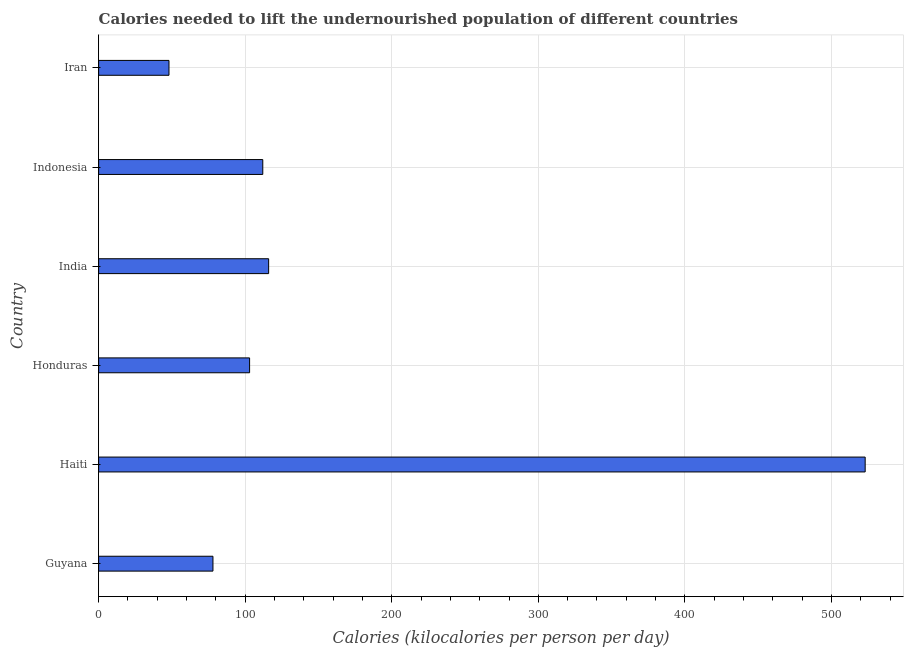What is the title of the graph?
Your answer should be very brief. Calories needed to lift the undernourished population of different countries. What is the label or title of the X-axis?
Offer a terse response. Calories (kilocalories per person per day). What is the depth of food deficit in Haiti?
Provide a short and direct response. 523. Across all countries, what is the maximum depth of food deficit?
Your response must be concise. 523. In which country was the depth of food deficit maximum?
Your answer should be very brief. Haiti. In which country was the depth of food deficit minimum?
Make the answer very short. Iran. What is the sum of the depth of food deficit?
Offer a very short reply. 980. What is the average depth of food deficit per country?
Give a very brief answer. 163.33. What is the median depth of food deficit?
Offer a terse response. 107.5. In how many countries, is the depth of food deficit greater than 340 kilocalories?
Keep it short and to the point. 1. What is the ratio of the depth of food deficit in Guyana to that in Haiti?
Provide a short and direct response. 0.15. Is the depth of food deficit in Haiti less than that in Honduras?
Provide a succinct answer. No. Is the difference between the depth of food deficit in India and Indonesia greater than the difference between any two countries?
Keep it short and to the point. No. What is the difference between the highest and the second highest depth of food deficit?
Offer a very short reply. 407. What is the difference between the highest and the lowest depth of food deficit?
Ensure brevity in your answer.  475. Are the values on the major ticks of X-axis written in scientific E-notation?
Provide a short and direct response. No. What is the Calories (kilocalories per person per day) in Guyana?
Provide a succinct answer. 78. What is the Calories (kilocalories per person per day) in Haiti?
Your answer should be very brief. 523. What is the Calories (kilocalories per person per day) of Honduras?
Your answer should be very brief. 103. What is the Calories (kilocalories per person per day) in India?
Give a very brief answer. 116. What is the Calories (kilocalories per person per day) in Indonesia?
Offer a terse response. 112. What is the difference between the Calories (kilocalories per person per day) in Guyana and Haiti?
Your answer should be compact. -445. What is the difference between the Calories (kilocalories per person per day) in Guyana and Honduras?
Provide a short and direct response. -25. What is the difference between the Calories (kilocalories per person per day) in Guyana and India?
Provide a succinct answer. -38. What is the difference between the Calories (kilocalories per person per day) in Guyana and Indonesia?
Provide a succinct answer. -34. What is the difference between the Calories (kilocalories per person per day) in Haiti and Honduras?
Keep it short and to the point. 420. What is the difference between the Calories (kilocalories per person per day) in Haiti and India?
Provide a succinct answer. 407. What is the difference between the Calories (kilocalories per person per day) in Haiti and Indonesia?
Make the answer very short. 411. What is the difference between the Calories (kilocalories per person per day) in Haiti and Iran?
Provide a succinct answer. 475. What is the difference between the Calories (kilocalories per person per day) in Honduras and India?
Your response must be concise. -13. What is the difference between the Calories (kilocalories per person per day) in Honduras and Indonesia?
Keep it short and to the point. -9. What is the difference between the Calories (kilocalories per person per day) in India and Indonesia?
Keep it short and to the point. 4. What is the ratio of the Calories (kilocalories per person per day) in Guyana to that in Haiti?
Provide a succinct answer. 0.15. What is the ratio of the Calories (kilocalories per person per day) in Guyana to that in Honduras?
Your answer should be compact. 0.76. What is the ratio of the Calories (kilocalories per person per day) in Guyana to that in India?
Offer a very short reply. 0.67. What is the ratio of the Calories (kilocalories per person per day) in Guyana to that in Indonesia?
Offer a terse response. 0.7. What is the ratio of the Calories (kilocalories per person per day) in Guyana to that in Iran?
Give a very brief answer. 1.62. What is the ratio of the Calories (kilocalories per person per day) in Haiti to that in Honduras?
Your answer should be very brief. 5.08. What is the ratio of the Calories (kilocalories per person per day) in Haiti to that in India?
Provide a short and direct response. 4.51. What is the ratio of the Calories (kilocalories per person per day) in Haiti to that in Indonesia?
Provide a short and direct response. 4.67. What is the ratio of the Calories (kilocalories per person per day) in Haiti to that in Iran?
Offer a terse response. 10.9. What is the ratio of the Calories (kilocalories per person per day) in Honduras to that in India?
Offer a terse response. 0.89. What is the ratio of the Calories (kilocalories per person per day) in Honduras to that in Iran?
Offer a very short reply. 2.15. What is the ratio of the Calories (kilocalories per person per day) in India to that in Indonesia?
Your answer should be compact. 1.04. What is the ratio of the Calories (kilocalories per person per day) in India to that in Iran?
Your response must be concise. 2.42. What is the ratio of the Calories (kilocalories per person per day) in Indonesia to that in Iran?
Your response must be concise. 2.33. 